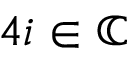Convert formula to latex. <formula><loc_0><loc_0><loc_500><loc_500>4 i \in \mathbb { C }</formula> 